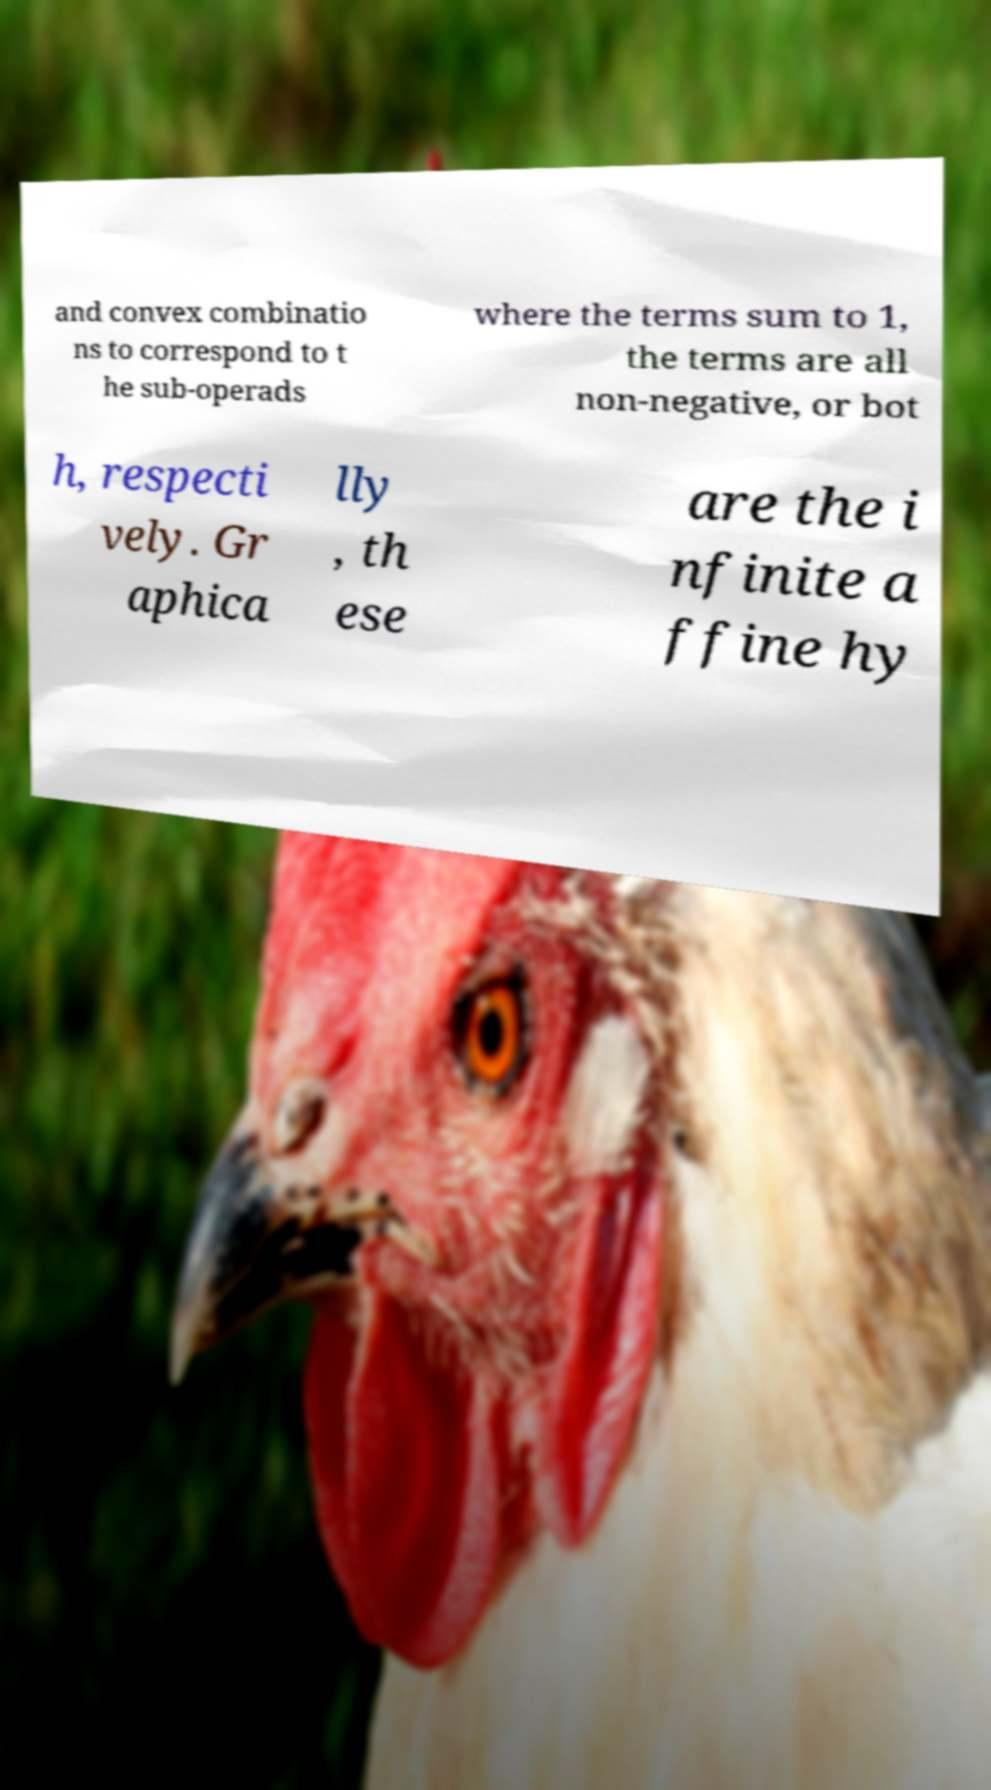Please read and relay the text visible in this image. What does it say? and convex combinatio ns to correspond to t he sub-operads where the terms sum to 1, the terms are all non-negative, or bot h, respecti vely. Gr aphica lly , th ese are the i nfinite a ffine hy 